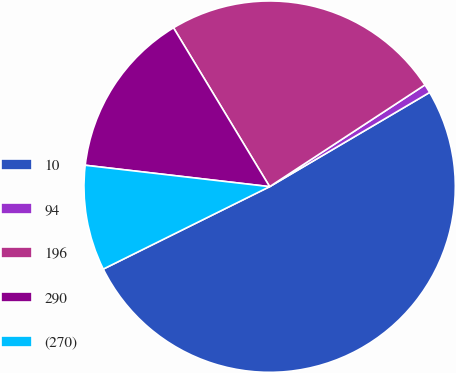<chart> <loc_0><loc_0><loc_500><loc_500><pie_chart><fcel>10<fcel>94<fcel>196<fcel>290<fcel>(270)<nl><fcel>51.15%<fcel>0.76%<fcel>24.43%<fcel>14.5%<fcel>9.16%<nl></chart> 